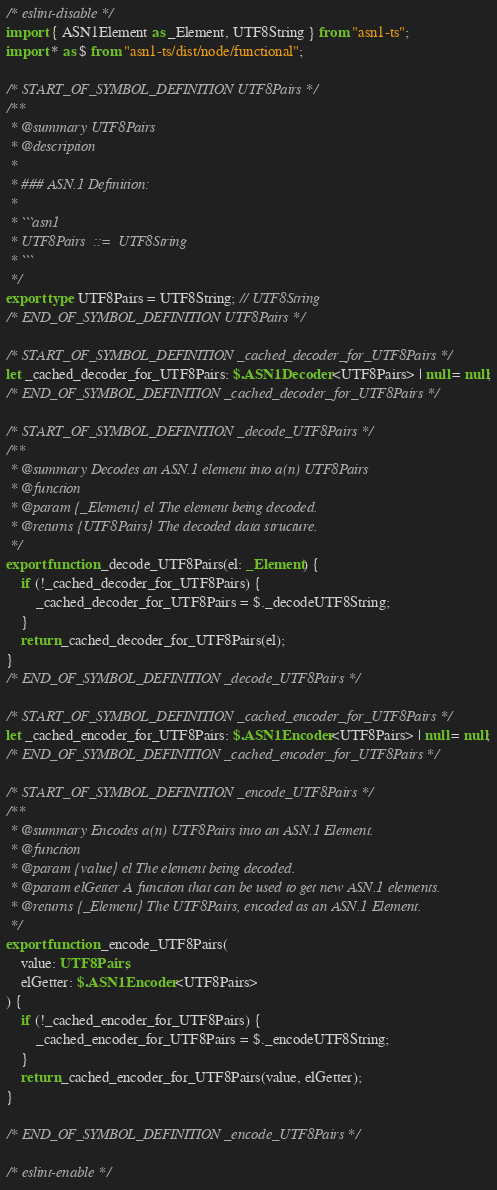<code> <loc_0><loc_0><loc_500><loc_500><_TypeScript_>/* eslint-disable */
import { ASN1Element as _Element, UTF8String } from "asn1-ts";
import * as $ from "asn1-ts/dist/node/functional";

/* START_OF_SYMBOL_DEFINITION UTF8Pairs */
/**
 * @summary UTF8Pairs
 * @description
 *
 * ### ASN.1 Definition:
 *
 * ```asn1
 * UTF8Pairs  ::=  UTF8String
 * ```
 */
export type UTF8Pairs = UTF8String; // UTF8String
/* END_OF_SYMBOL_DEFINITION UTF8Pairs */

/* START_OF_SYMBOL_DEFINITION _cached_decoder_for_UTF8Pairs */
let _cached_decoder_for_UTF8Pairs: $.ASN1Decoder<UTF8Pairs> | null = null;
/* END_OF_SYMBOL_DEFINITION _cached_decoder_for_UTF8Pairs */

/* START_OF_SYMBOL_DEFINITION _decode_UTF8Pairs */
/**
 * @summary Decodes an ASN.1 element into a(n) UTF8Pairs
 * @function
 * @param {_Element} el The element being decoded.
 * @returns {UTF8Pairs} The decoded data structure.
 */
export function _decode_UTF8Pairs(el: _Element) {
    if (!_cached_decoder_for_UTF8Pairs) {
        _cached_decoder_for_UTF8Pairs = $._decodeUTF8String;
    }
    return _cached_decoder_for_UTF8Pairs(el);
}
/* END_OF_SYMBOL_DEFINITION _decode_UTF8Pairs */

/* START_OF_SYMBOL_DEFINITION _cached_encoder_for_UTF8Pairs */
let _cached_encoder_for_UTF8Pairs: $.ASN1Encoder<UTF8Pairs> | null = null;
/* END_OF_SYMBOL_DEFINITION _cached_encoder_for_UTF8Pairs */

/* START_OF_SYMBOL_DEFINITION _encode_UTF8Pairs */
/**
 * @summary Encodes a(n) UTF8Pairs into an ASN.1 Element.
 * @function
 * @param {value} el The element being decoded.
 * @param elGetter A function that can be used to get new ASN.1 elements.
 * @returns {_Element} The UTF8Pairs, encoded as an ASN.1 Element.
 */
export function _encode_UTF8Pairs(
    value: UTF8Pairs,
    elGetter: $.ASN1Encoder<UTF8Pairs>
) {
    if (!_cached_encoder_for_UTF8Pairs) {
        _cached_encoder_for_UTF8Pairs = $._encodeUTF8String;
    }
    return _cached_encoder_for_UTF8Pairs(value, elGetter);
}

/* END_OF_SYMBOL_DEFINITION _encode_UTF8Pairs */

/* eslint-enable */
</code> 